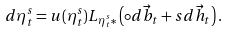Convert formula to latex. <formula><loc_0><loc_0><loc_500><loc_500>d \eta _ { t } ^ { s } = u ( \eta _ { t } ^ { s } ) L _ { \eta _ { t } ^ { s } * } \left ( \circ d \vec { b } _ { t } + s d \vec { h } _ { t } \right ) .</formula> 